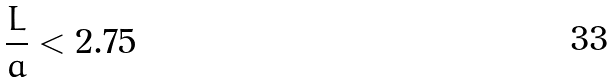<formula> <loc_0><loc_0><loc_500><loc_500>\frac { L } { a } < 2 . 7 5</formula> 